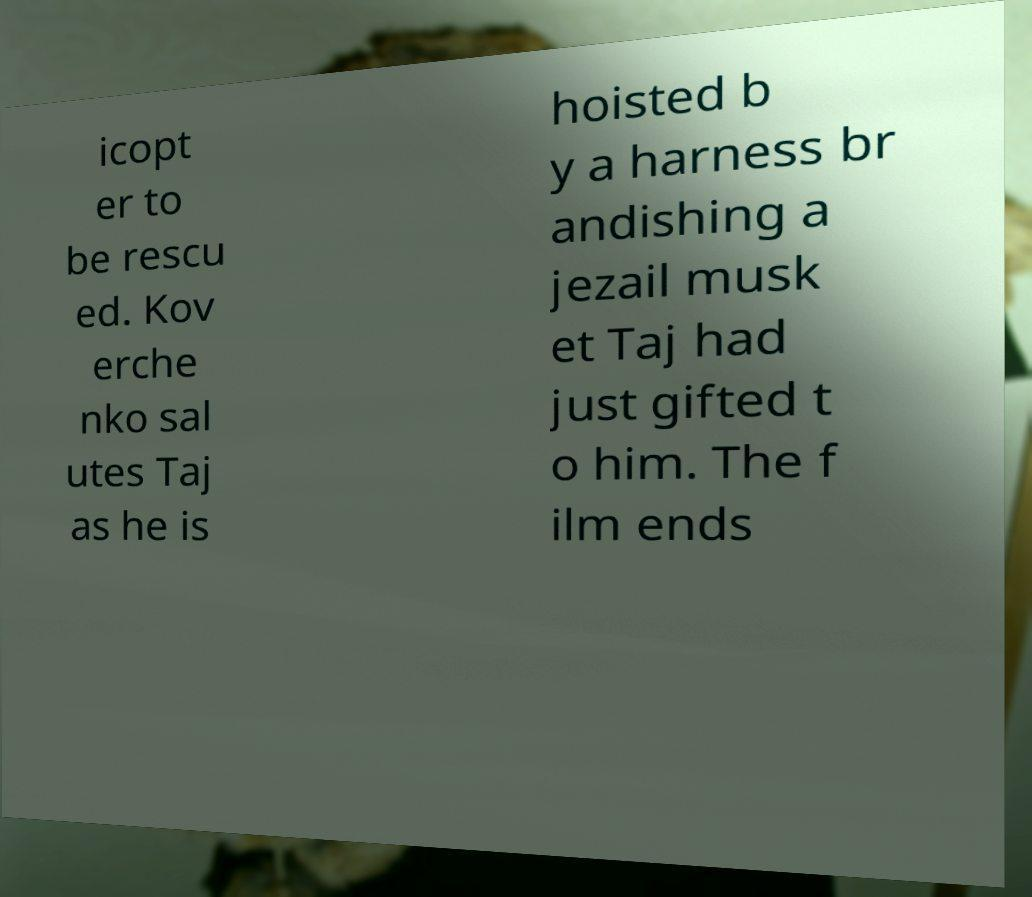For documentation purposes, I need the text within this image transcribed. Could you provide that? icopt er to be rescu ed. Kov erche nko sal utes Taj as he is hoisted b y a harness br andishing a jezail musk et Taj had just gifted t o him. The f ilm ends 